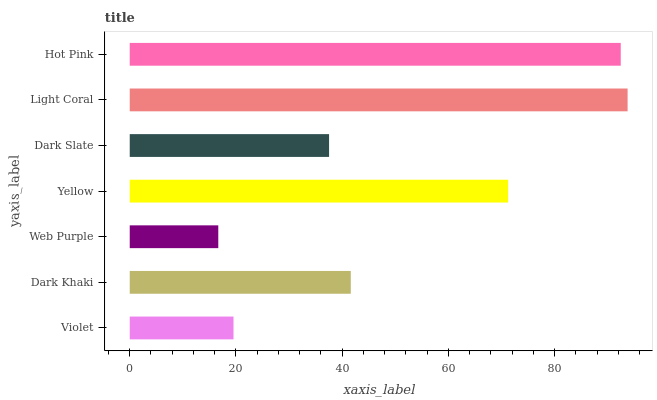Is Web Purple the minimum?
Answer yes or no. Yes. Is Light Coral the maximum?
Answer yes or no. Yes. Is Dark Khaki the minimum?
Answer yes or no. No. Is Dark Khaki the maximum?
Answer yes or no. No. Is Dark Khaki greater than Violet?
Answer yes or no. Yes. Is Violet less than Dark Khaki?
Answer yes or no. Yes. Is Violet greater than Dark Khaki?
Answer yes or no. No. Is Dark Khaki less than Violet?
Answer yes or no. No. Is Dark Khaki the high median?
Answer yes or no. Yes. Is Dark Khaki the low median?
Answer yes or no. Yes. Is Yellow the high median?
Answer yes or no. No. Is Yellow the low median?
Answer yes or no. No. 